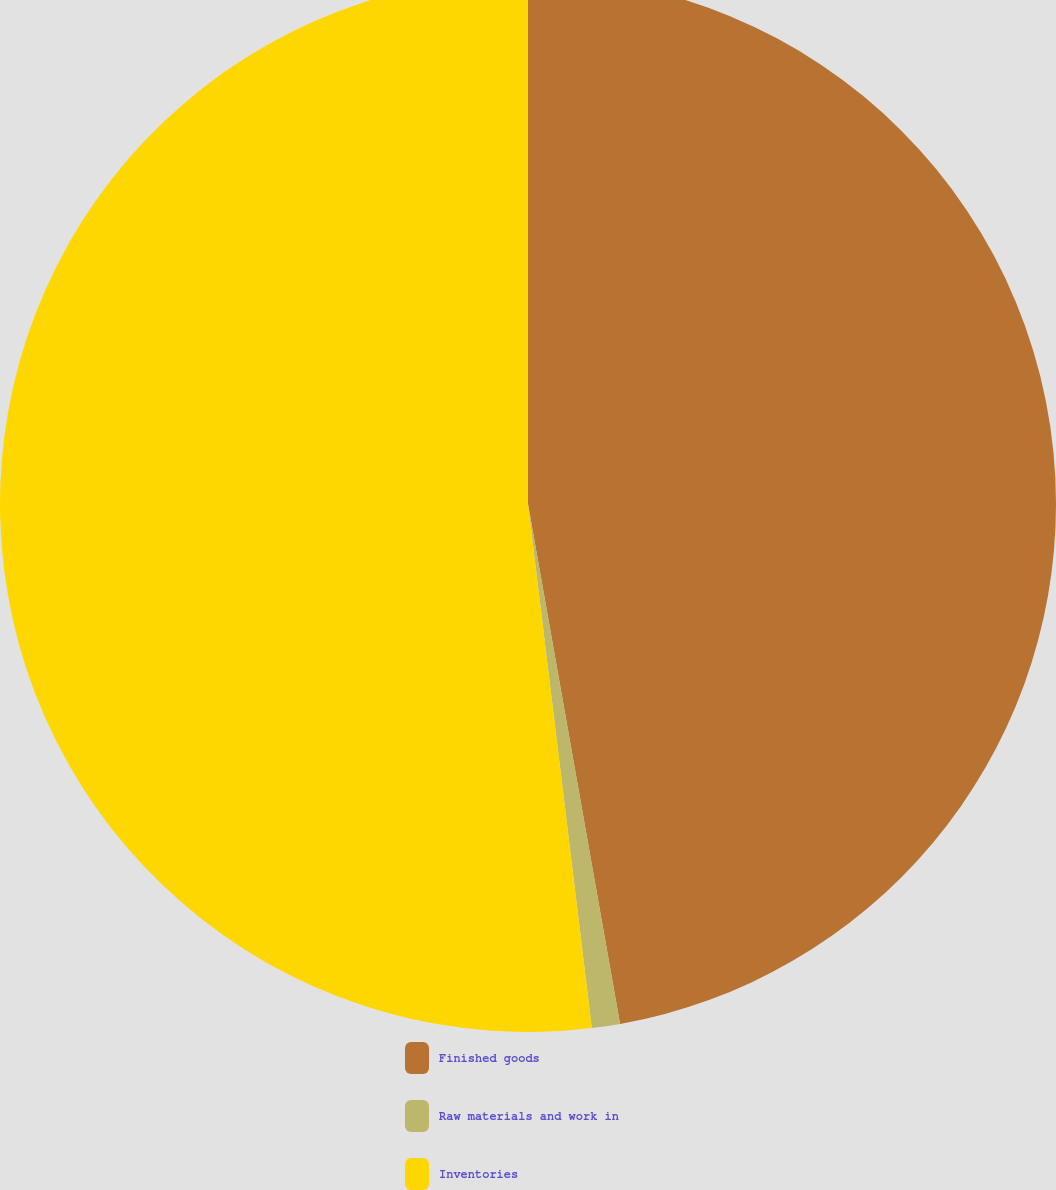<chart> <loc_0><loc_0><loc_500><loc_500><pie_chart><fcel>Finished goods<fcel>Raw materials and work in<fcel>Inventories<nl><fcel>47.21%<fcel>0.86%<fcel>51.93%<nl></chart> 